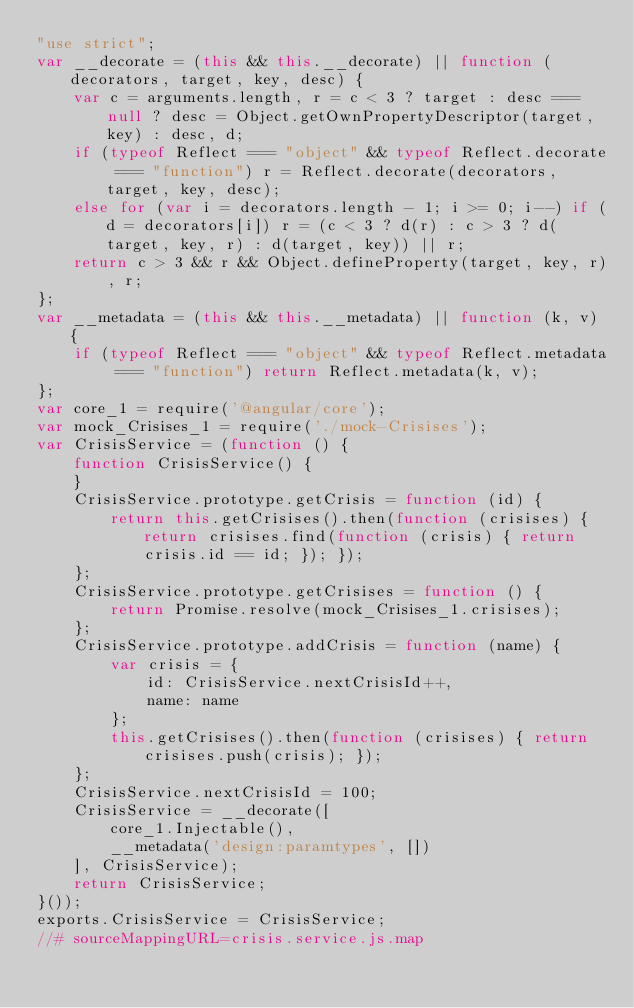<code> <loc_0><loc_0><loc_500><loc_500><_JavaScript_>"use strict";
var __decorate = (this && this.__decorate) || function (decorators, target, key, desc) {
    var c = arguments.length, r = c < 3 ? target : desc === null ? desc = Object.getOwnPropertyDescriptor(target, key) : desc, d;
    if (typeof Reflect === "object" && typeof Reflect.decorate === "function") r = Reflect.decorate(decorators, target, key, desc);
    else for (var i = decorators.length - 1; i >= 0; i--) if (d = decorators[i]) r = (c < 3 ? d(r) : c > 3 ? d(target, key, r) : d(target, key)) || r;
    return c > 3 && r && Object.defineProperty(target, key, r), r;
};
var __metadata = (this && this.__metadata) || function (k, v) {
    if (typeof Reflect === "object" && typeof Reflect.metadata === "function") return Reflect.metadata(k, v);
};
var core_1 = require('@angular/core');
var mock_Crisises_1 = require('./mock-Crisises');
var CrisisService = (function () {
    function CrisisService() {
    }
    CrisisService.prototype.getCrisis = function (id) {
        return this.getCrisises().then(function (crisises) { return crisises.find(function (crisis) { return crisis.id == id; }); });
    };
    CrisisService.prototype.getCrisises = function () {
        return Promise.resolve(mock_Crisises_1.crisises);
    };
    CrisisService.prototype.addCrisis = function (name) {
        var crisis = {
            id: CrisisService.nextCrisisId++,
            name: name
        };
        this.getCrisises().then(function (crisises) { return crisises.push(crisis); });
    };
    CrisisService.nextCrisisId = 100;
    CrisisService = __decorate([
        core_1.Injectable(), 
        __metadata('design:paramtypes', [])
    ], CrisisService);
    return CrisisService;
}());
exports.CrisisService = CrisisService;
//# sourceMappingURL=crisis.service.js.map</code> 